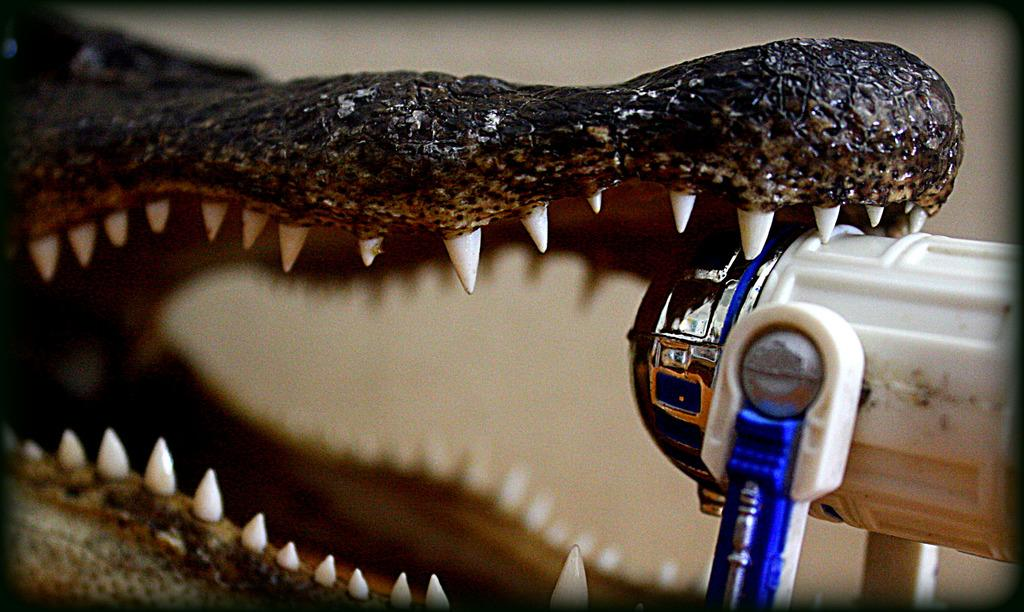What is the main subject of the image? There is a sculpture of a crocodile in the image. Can you describe the object on the right side of the image? Unfortunately, the provided facts do not give any information about the object on the right side of the image. What type of vest is the kitten wearing in the image? There is no kitten or vest present in the image. Can you tell me how many monkeys are climbing on the sculpture in the image? There is no mention of monkeys in the provided facts, and the image only features a sculpture of a crocodile. 